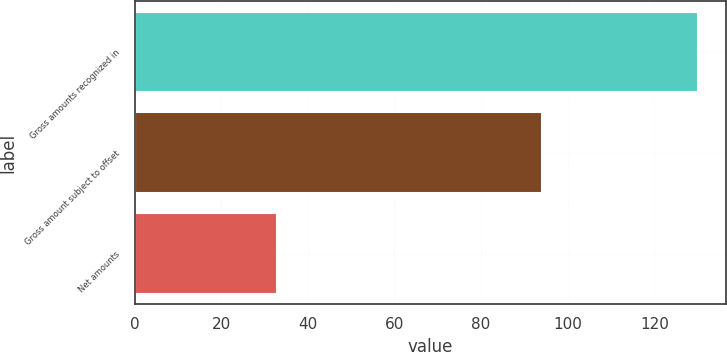<chart> <loc_0><loc_0><loc_500><loc_500><bar_chart><fcel>Gross amounts recognized in<fcel>Gross amount subject to offset<fcel>Net amounts<nl><fcel>130<fcel>94<fcel>33<nl></chart> 